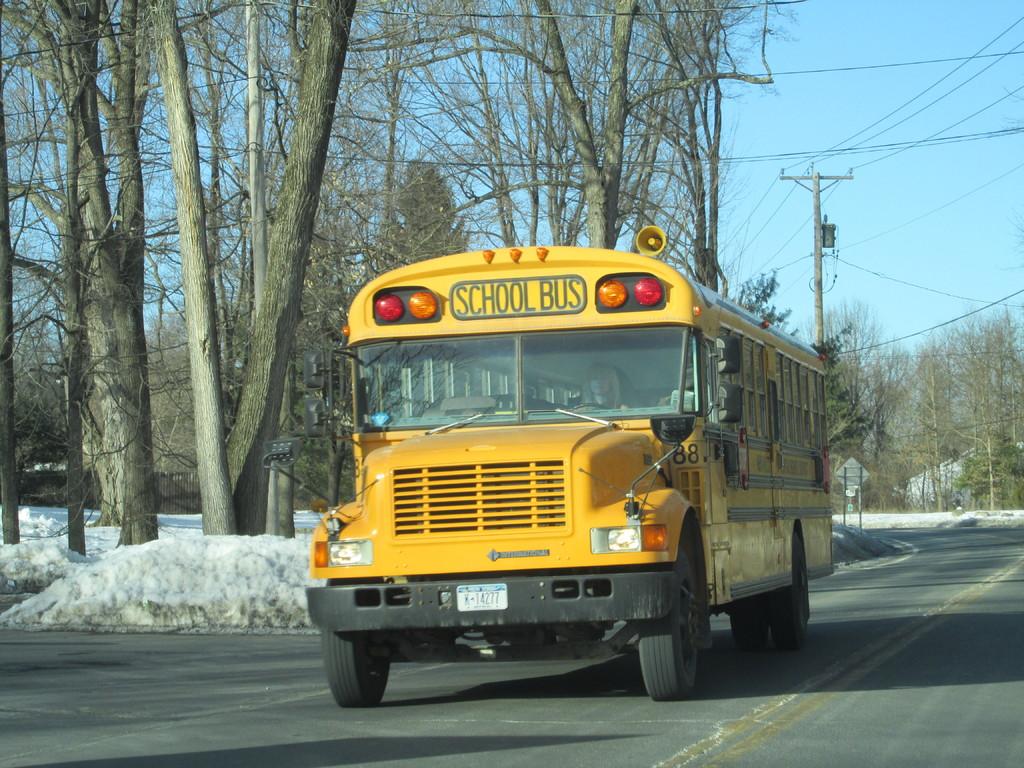What kind of vehicle is this?
Your response must be concise. School bus. What does the license plate say?
Your answer should be compact. K-14277. 